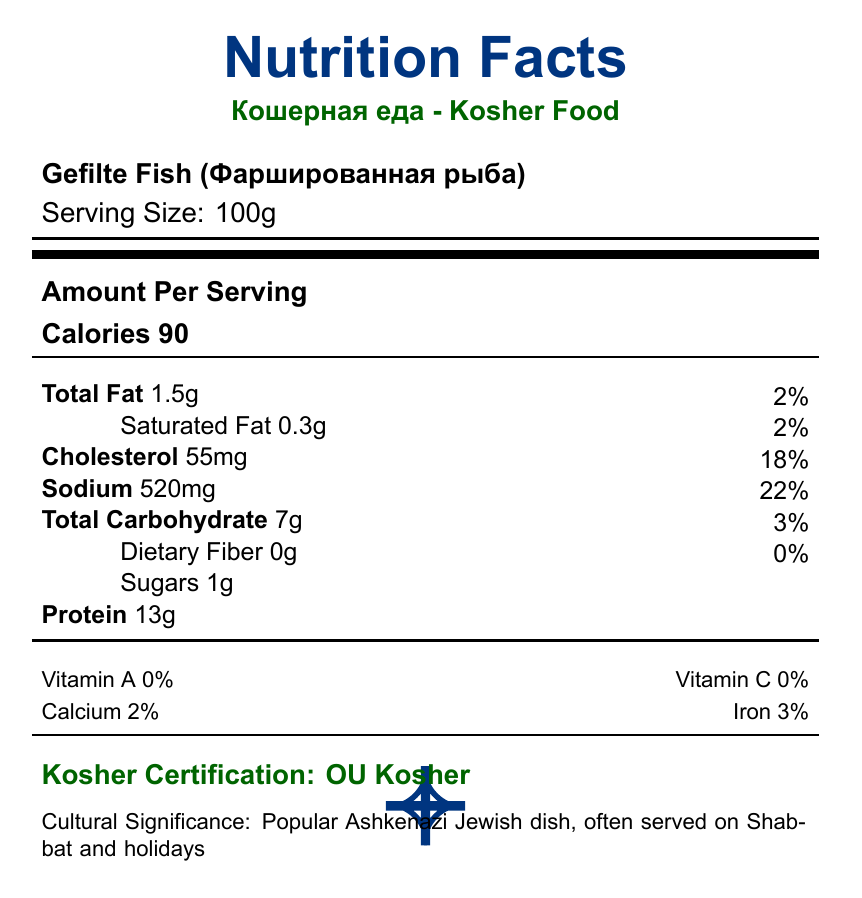What is the serving size for Gefilte Fish? The serving size is labeled clearly as 100g.
Answer: 100g How much cholesterol is in a serving of Gefilte Fish? The document specifies that there are 55mg of cholesterol in a serving of Gefilte Fish.
Answer: 55mg What percentage of the daily value for sodium does Gefilte Fish contain per serving? The document notes that a serving of Gefilte Fish contains 520mg of sodium, which represents 22% of the daily value.
Answer: 22% What is the kosher certification for Gefilte Fish? The kosher certification is clearly mentioned as "OU Kosher."
Answer: OU Kosher How many grams of protein are in a serving of Gefilte Fish? The document specifies that Gefilte Fish contains 13g of protein per serving.
Answer: 13g Which nutrient has a higher percentage of daily value in Gefilte Fish, Total Fat or Iron? A. Total Fat B. Iron The Iron content has a daily value percentage of 3%, whereas Total Fat content is listed with a 2% daily value.
Answer: B. Iron What is the cultural significance of Gefilte Fish? A. Used in Passover Seder B. Served on Shabbat and holidays C. Traditional Hanukkah dish D. Popular in Russian-Jewish cuisine The document notes that Gefilte Fish is popular in Ashkenazi Jewish cuisine and is often served on Shabbat and holidays.
Answer: B. Served on Shabbat and holidays Is Vitamin C present in Gefilte Fish? The document states that Vitamin C is 0%, indicating no Vitamin C content.
Answer: No Which kosher certification body is headquartered in New York, USA? The document lists the Orthodox Union (OU) with headquarters in New York, USA.
Answer: Orthodox Union (OU) Summarize the nutritional information and cultural significance of Gefilte Fish. This summary encompasses the key nutritional components of Gefilte Fish, its cultural significance, and kosher certification details.
Answer: Gefilte Fish, or Фаршированная рыба, is a popular Ashkenazi Jewish dish often served on Shabbat and holidays. It has a serving size of 100g and contains 90 calories, 1.5g of total fat, 0.3g of saturated fat, 55mg of cholesterol, 520mg of sodium, 7g of total carbohydrates (1g of sugars), and 13g of protein. It has 0% daily value for Vitamin A and C, 2% Calcium, and 3% Iron. The dish has OU Kosher certification. Which vitamin is entirely absent from Gefilte Fish? The document shows that Vitamin A content is 0%, indicating it is entirely absent.
Answer: Vitamin A What adjustments might be needed for someone concerned about sodium intake? Sodium content is 520mg which represents 22% of the daily value, which is relatively high.
Answer: Modify recipes to reduce salt content or balance with low-sodium side dishes. What is the cultural significance of Matzo Ball Soup mentioned in the document? The question asks about Matzo Ball Soup, but the document provided is only about Gefilte Fish.
Answer: Cannot be determined What nutritional consideration explains the high sodium content in many traditional Jewish dishes? A. Due to preservation methods and flavor enhancement B. Due to the use of fresh ingredients C. Due to low-fat preparation D. Due to high protein content The nutritional consideration mentions that traditional Jewish dishes tend to be high in sodium due to preservation methods and flavor enhancement.
Answer: A. Due to preservation methods and flavor enhancement What would be the best way to increase the fiber content in the traditional Jewish diet? The nutritional consideration suggests increasing fiber intake by adding more whole grains and legumes to traditional recipes.
Answer: Incorporate more whole grains and legumes into traditional recipes. 